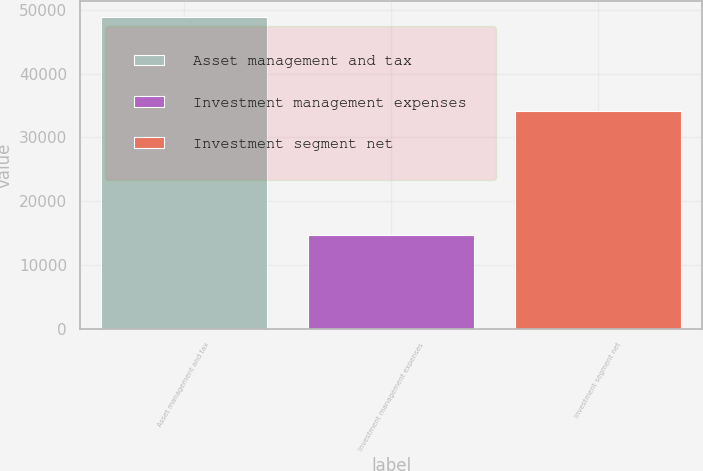Convert chart. <chart><loc_0><loc_0><loc_500><loc_500><bar_chart><fcel>Asset management and tax<fcel>Investment management expenses<fcel>Investment segment net<nl><fcel>48893<fcel>14742<fcel>34151<nl></chart> 